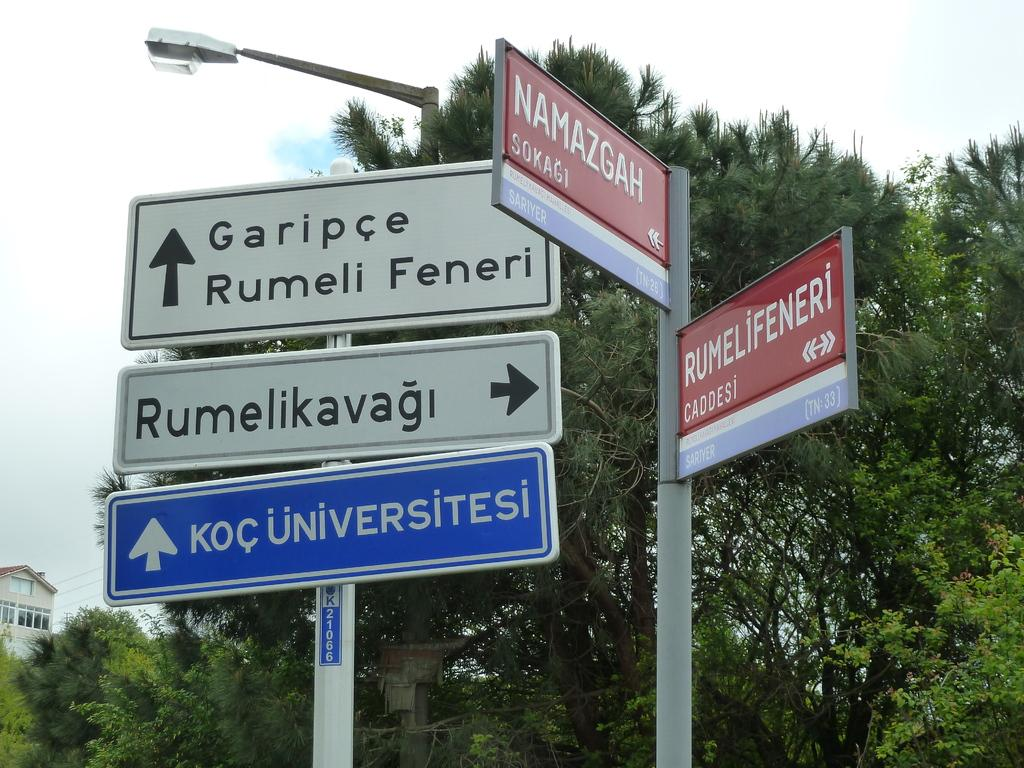<image>
Offer a succinct explanation of the picture presented. Several road signs are together including one that has an arrow and Garipce. 